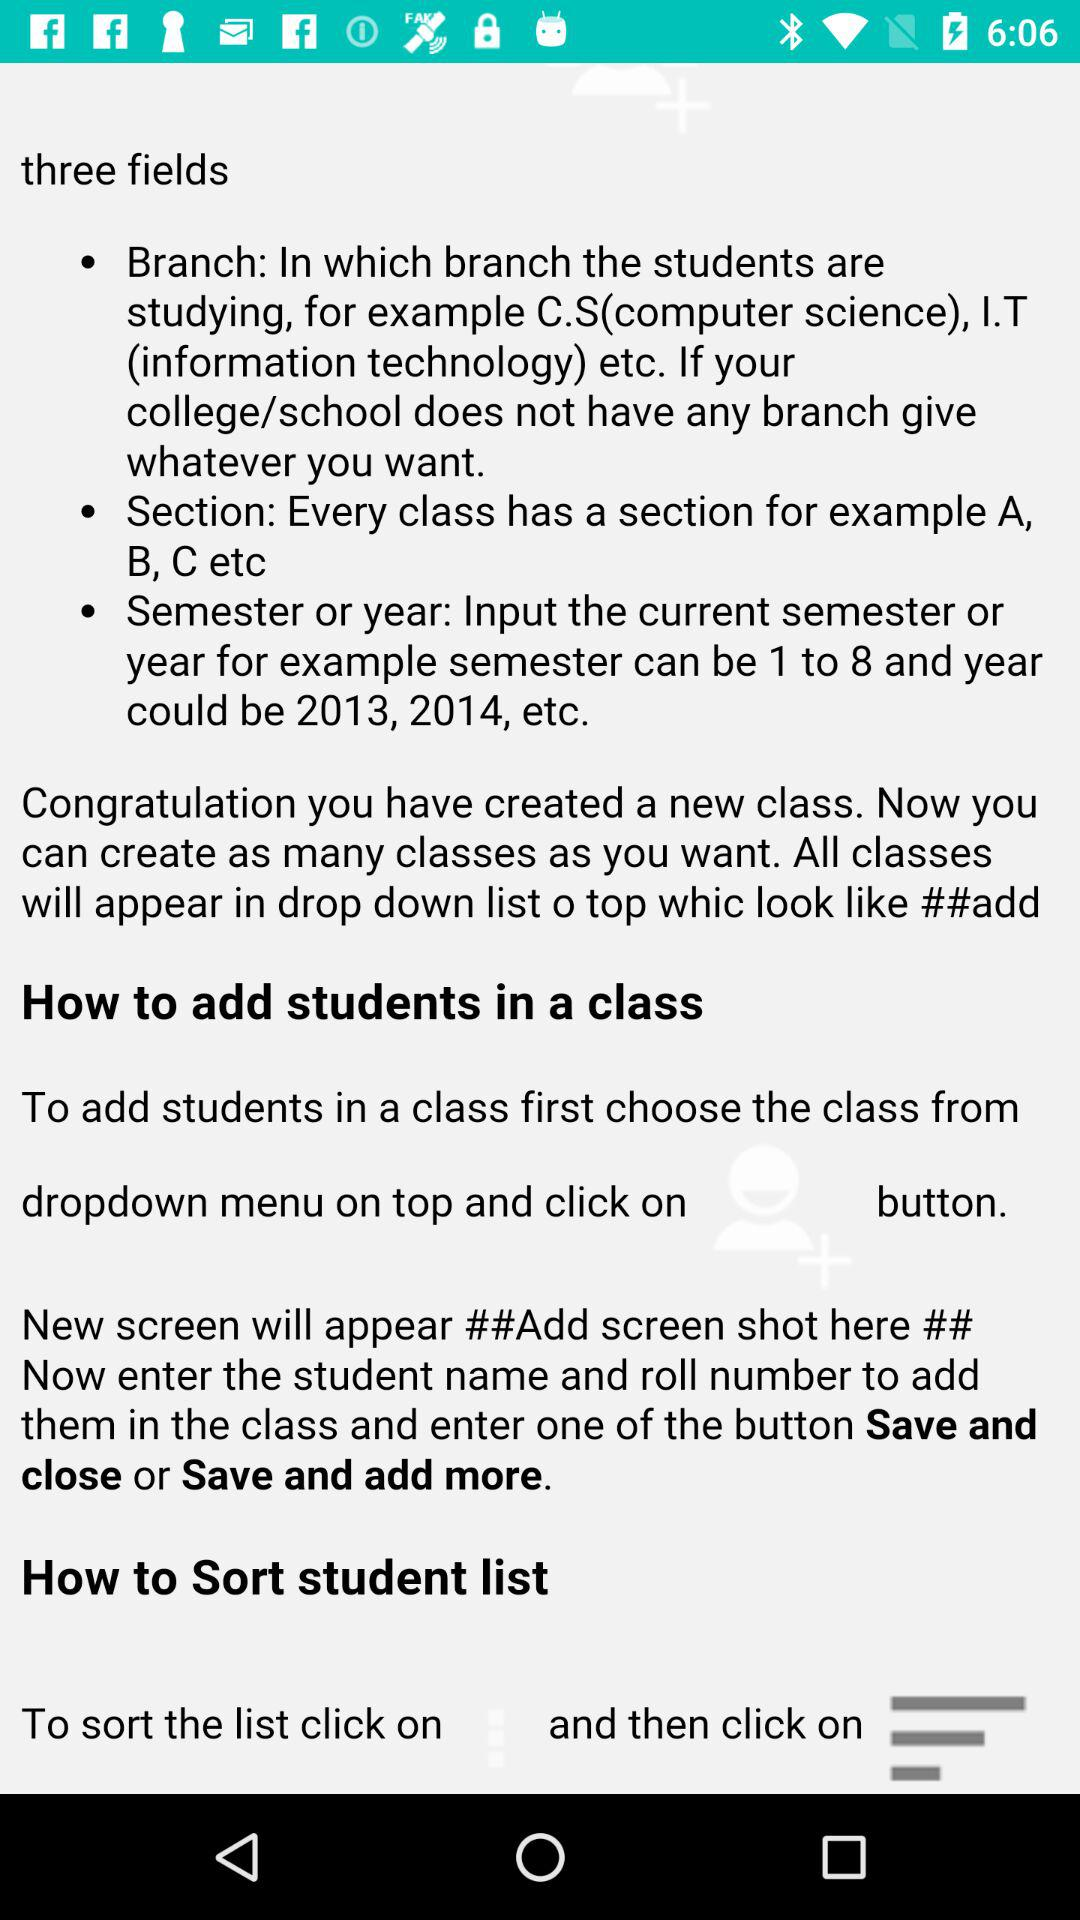How many steps are there to add students to a class?
Answer the question using a single word or phrase. 3 